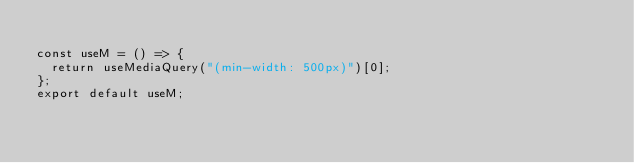<code> <loc_0><loc_0><loc_500><loc_500><_JavaScript_>
const useM = () => {
  return useMediaQuery("(min-width: 500px)")[0];
};
export default useM;
</code> 